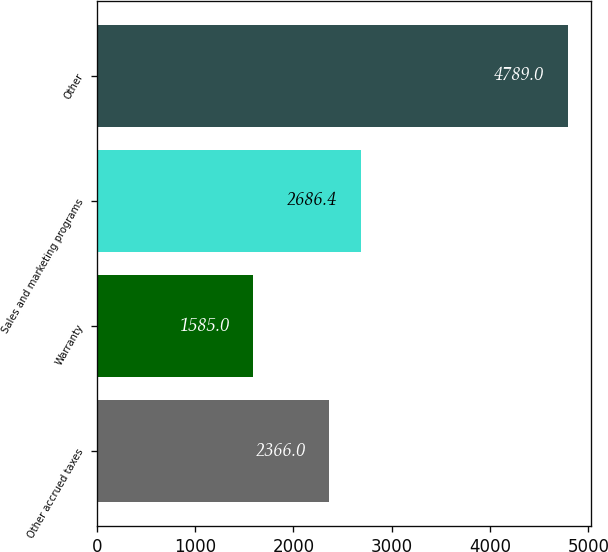<chart> <loc_0><loc_0><loc_500><loc_500><bar_chart><fcel>Other accrued taxes<fcel>Warranty<fcel>Sales and marketing programs<fcel>Other<nl><fcel>2366<fcel>1585<fcel>2686.4<fcel>4789<nl></chart> 